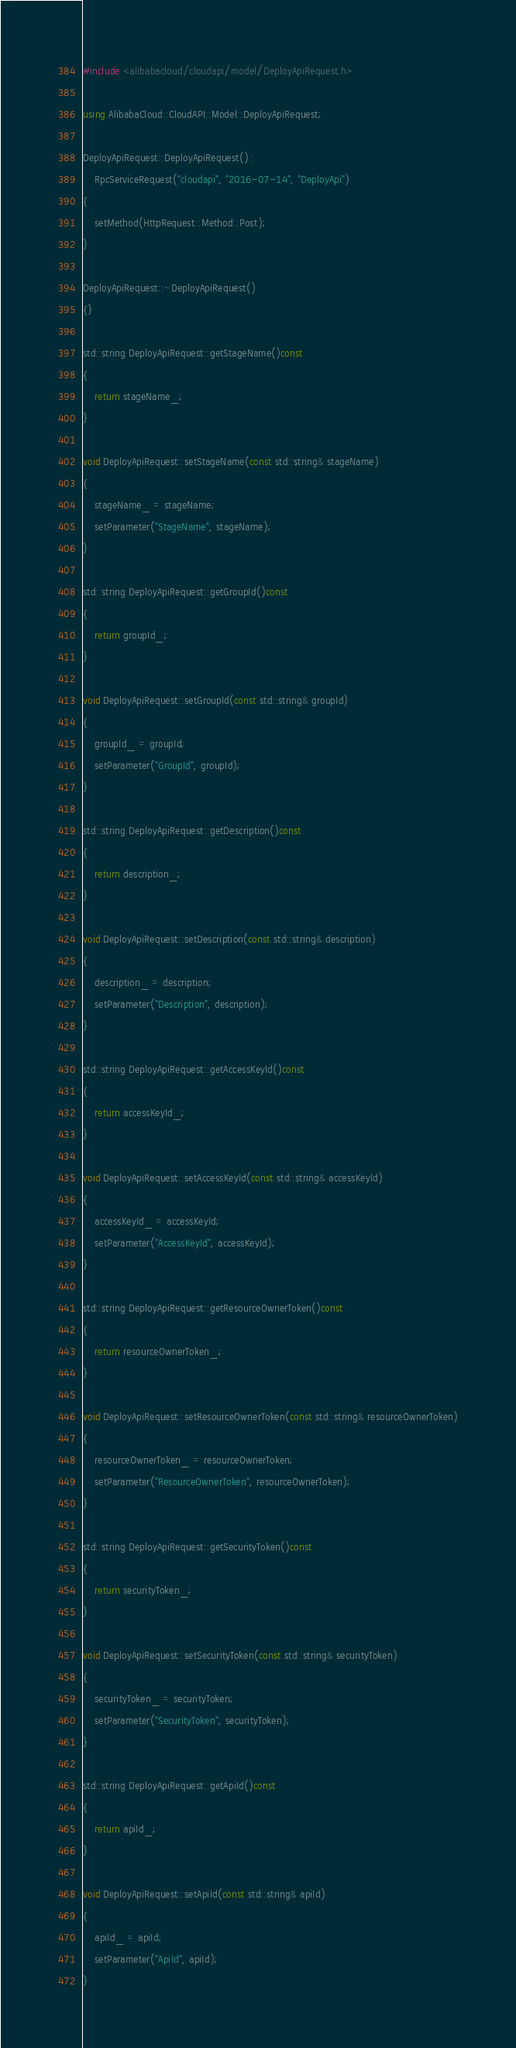<code> <loc_0><loc_0><loc_500><loc_500><_C++_>#include <alibabacloud/cloudapi/model/DeployApiRequest.h>

using AlibabaCloud::CloudAPI::Model::DeployApiRequest;

DeployApiRequest::DeployApiRequest() :
	RpcServiceRequest("cloudapi", "2016-07-14", "DeployApi")
{
	setMethod(HttpRequest::Method::Post);
}

DeployApiRequest::~DeployApiRequest()
{}

std::string DeployApiRequest::getStageName()const
{
	return stageName_;
}

void DeployApiRequest::setStageName(const std::string& stageName)
{
	stageName_ = stageName;
	setParameter("StageName", stageName);
}

std::string DeployApiRequest::getGroupId()const
{
	return groupId_;
}

void DeployApiRequest::setGroupId(const std::string& groupId)
{
	groupId_ = groupId;
	setParameter("GroupId", groupId);
}

std::string DeployApiRequest::getDescription()const
{
	return description_;
}

void DeployApiRequest::setDescription(const std::string& description)
{
	description_ = description;
	setParameter("Description", description);
}

std::string DeployApiRequest::getAccessKeyId()const
{
	return accessKeyId_;
}

void DeployApiRequest::setAccessKeyId(const std::string& accessKeyId)
{
	accessKeyId_ = accessKeyId;
	setParameter("AccessKeyId", accessKeyId);
}

std::string DeployApiRequest::getResourceOwnerToken()const
{
	return resourceOwnerToken_;
}

void DeployApiRequest::setResourceOwnerToken(const std::string& resourceOwnerToken)
{
	resourceOwnerToken_ = resourceOwnerToken;
	setParameter("ResourceOwnerToken", resourceOwnerToken);
}

std::string DeployApiRequest::getSecurityToken()const
{
	return securityToken_;
}

void DeployApiRequest::setSecurityToken(const std::string& securityToken)
{
	securityToken_ = securityToken;
	setParameter("SecurityToken", securityToken);
}

std::string DeployApiRequest::getApiId()const
{
	return apiId_;
}

void DeployApiRequest::setApiId(const std::string& apiId)
{
	apiId_ = apiId;
	setParameter("ApiId", apiId);
}

</code> 